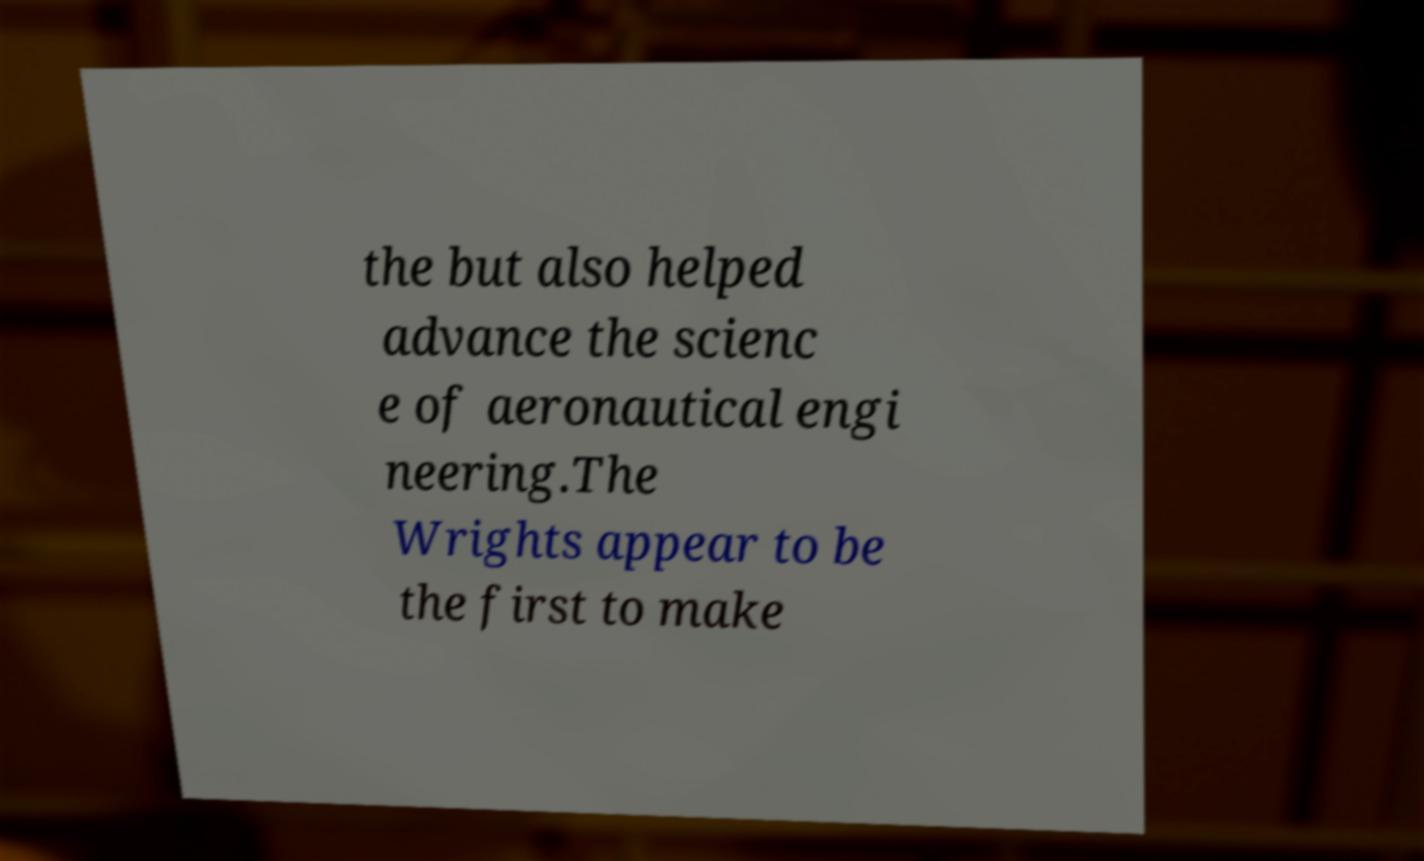I need the written content from this picture converted into text. Can you do that? the but also helped advance the scienc e of aeronautical engi neering.The Wrights appear to be the first to make 